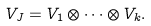<formula> <loc_0><loc_0><loc_500><loc_500>V _ { J } = V _ { 1 } \otimes \cdots \otimes V _ { k } .</formula> 